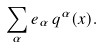Convert formula to latex. <formula><loc_0><loc_0><loc_500><loc_500>\sum _ { \alpha } e _ { \alpha } \, q ^ { \alpha } ( x ) .</formula> 